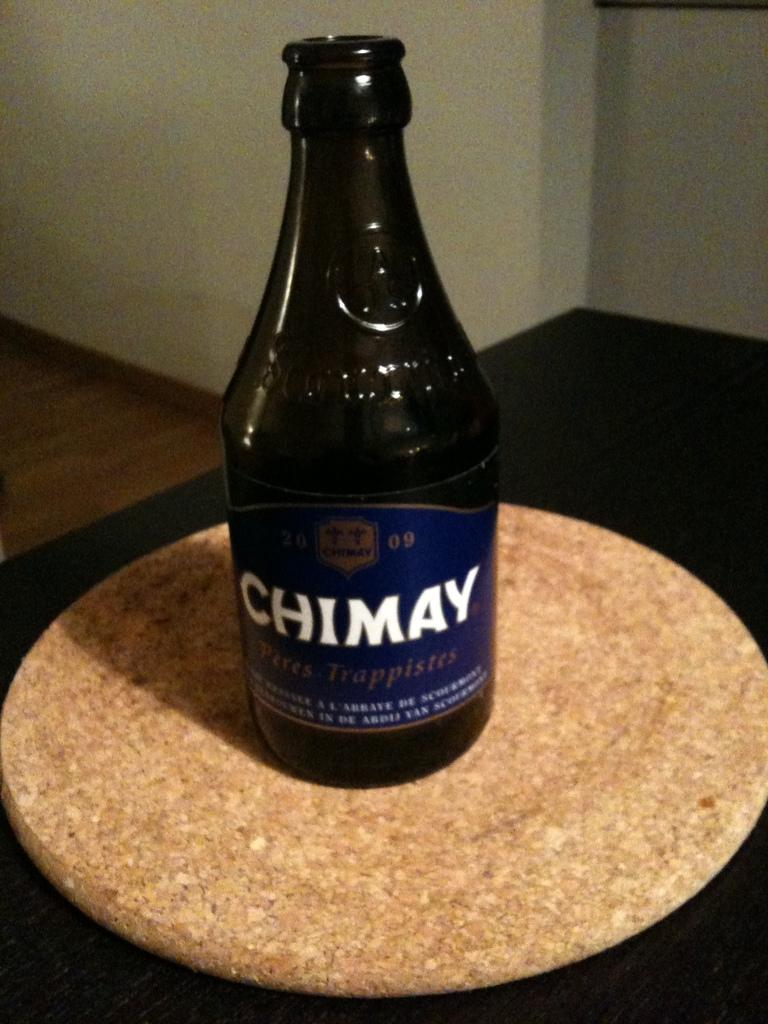<image>
Summarize the visual content of the image. The label on a bottle of beer reads "Chimay." 